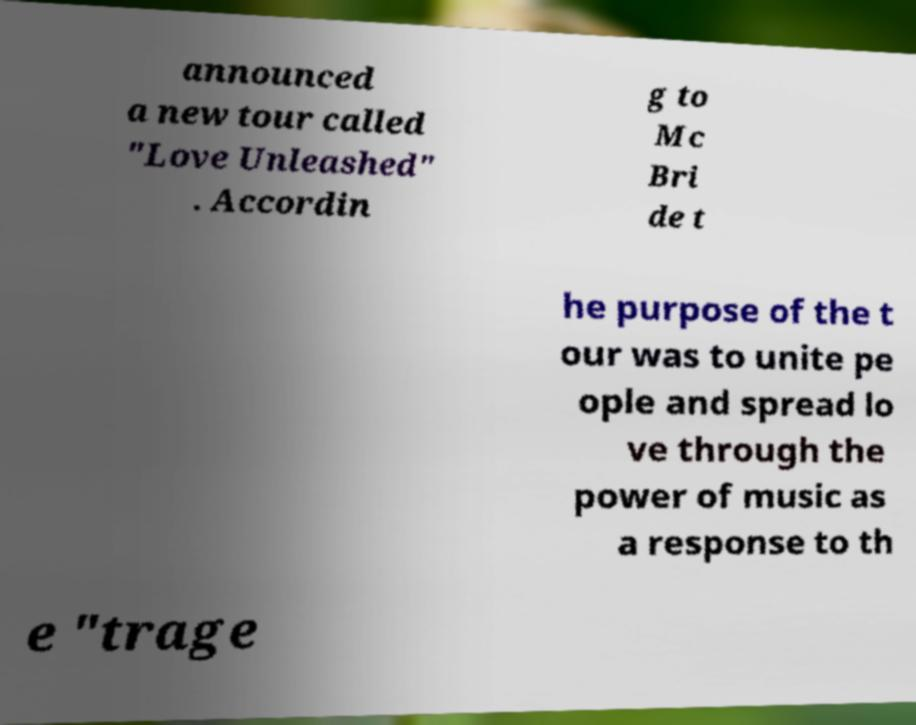For documentation purposes, I need the text within this image transcribed. Could you provide that? announced a new tour called "Love Unleashed" . Accordin g to Mc Bri de t he purpose of the t our was to unite pe ople and spread lo ve through the power of music as a response to th e "trage 